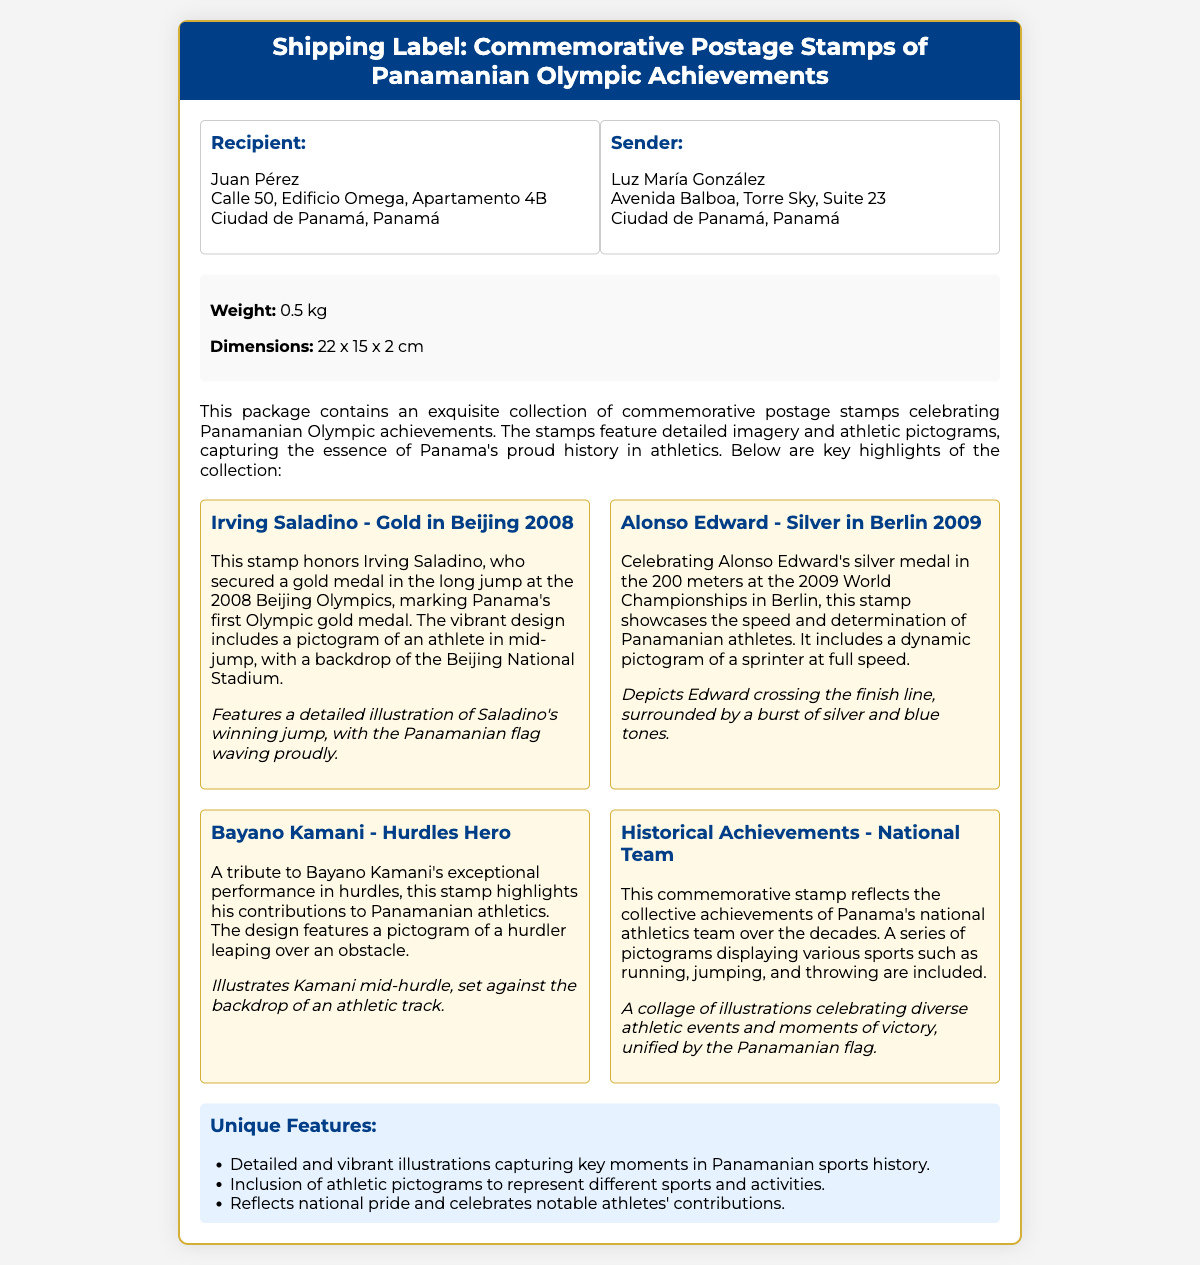What is the weight of the package? The weight of the package is clearly stated in the package info section, which is 0.5 kg.
Answer: 0.5 kg Who is the recipient of the package? The recipient's name is listed in the address section as Juan Pérez.
Answer: Juan Pérez What is the title of the document? The title of the document is prominently displayed in the header of the shipping label.
Answer: Shipping Label: Commemorative Postage Stamps of Panamanian Olympic Achievements Which Panamanian athlete is featured on the stamp for the 2008 Olympics? The stamp highlighting the 2008 Olympics features Irving Saladino, who won a gold medal.
Answer: Irving Saladino What unique design feature is included on the stamps? The document mentions that the stamps include athletic pictograms to represent various sports and activities.
Answer: Athletic pictograms How many stamps are listed in the document? The stamp list section contains four distinct stamps celebrating different Panamanian athletes and achievements.
Answer: Four What is the sender's name? The sender's name is provided in the address section as Luz María González.
Answer: Luz María González Which event did Alonso Edward win a medal in? The document states that Alonso Edward won a silver medal in the 200 meters at the 2009 World Championships.
Answer: 200 meters What background is featured on the Irving Saladino stamp? The design of the Irving Saladino stamp includes a backdrop of the Beijing National Stadium.
Answer: Beijing National Stadium 